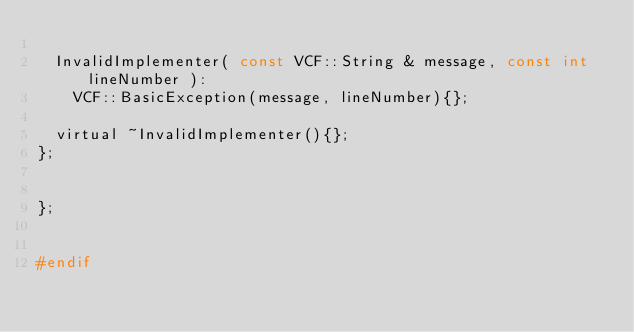<code> <loc_0><loc_0><loc_500><loc_500><_C_>
	InvalidImplementer( const VCF::String & message, const int lineNumber ):
		VCF::BasicException(message, lineNumber){};

	virtual ~InvalidImplementer(){};
};


};


#endif</code> 